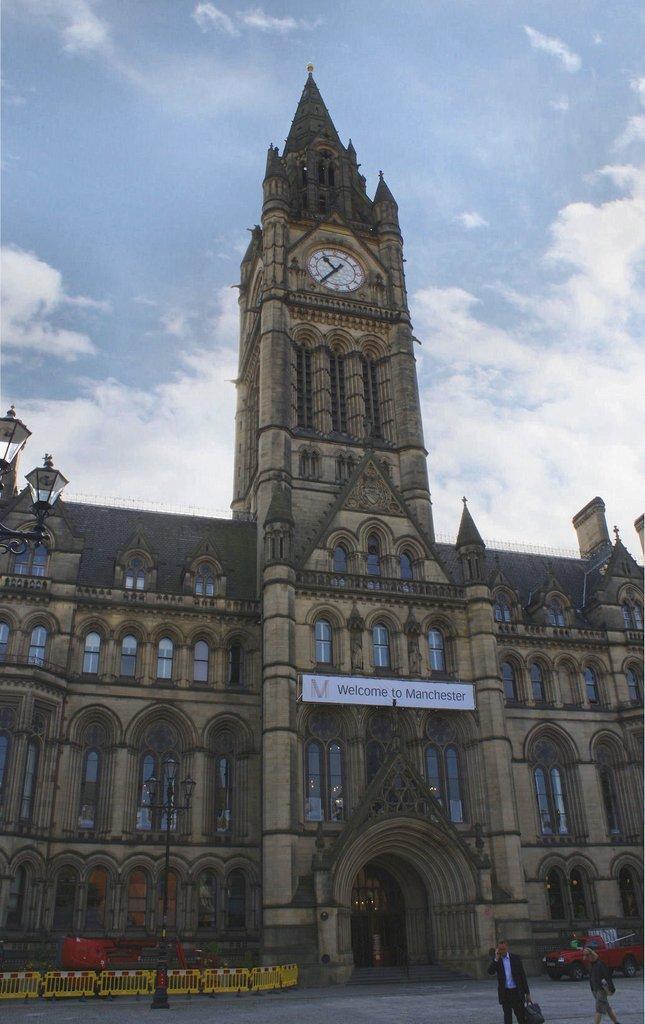Can you describe this image briefly? In the center of the image we can see building. In the background we can see sky and clouds. At the bottom there are persons and vehicle. 